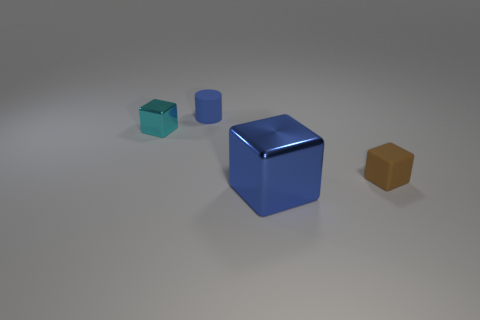Add 4 big purple shiny cylinders. How many objects exist? 8 Subtract all blocks. How many objects are left? 1 Add 4 large red cylinders. How many large red cylinders exist? 4 Subtract 0 brown cylinders. How many objects are left? 4 Subtract all small yellow cylinders. Subtract all cyan shiny cubes. How many objects are left? 3 Add 4 cyan cubes. How many cyan cubes are left? 5 